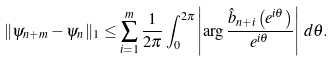<formula> <loc_0><loc_0><loc_500><loc_500>\| \psi _ { n + m } - \psi _ { n } \| _ { 1 } \leq \sum _ { i = 1 } ^ { m } \frac { 1 } { 2 \pi } \int _ { 0 } ^ { 2 \pi } \left | \arg \frac { \hat { b } _ { n + i } \left ( e ^ { i \theta } \right ) } { e ^ { i \theta } } \right | \, d \theta .</formula> 